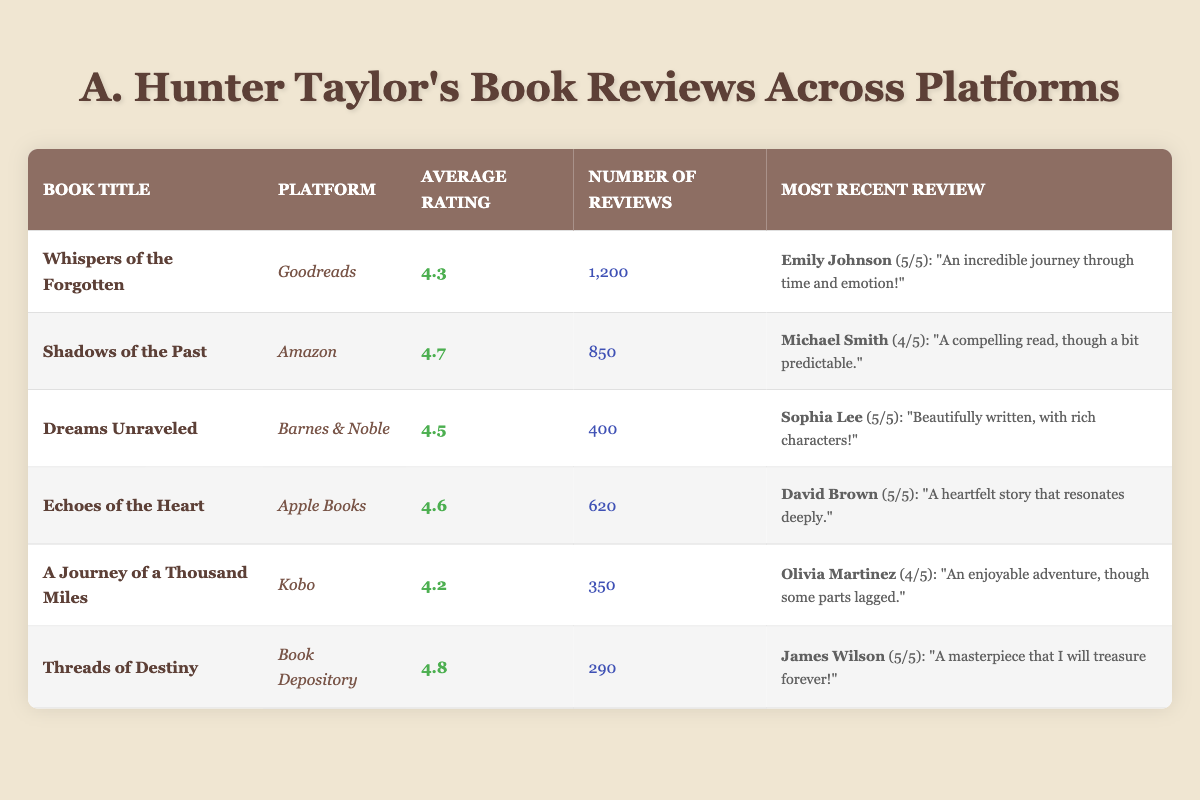What is the average rating of "Whispers of the Forgotten"? The table states that "Whispers of the Forgotten" has an average rating of 4.3 from Goodreads.
Answer: 4.3 Which book has the highest average rating? Upon reviewing the average ratings listed, "Threads of Destiny" has the highest rating of 4.8 among the books.
Answer: Threads of Destiny How many total reviews are there for all books combined? By adding the number of reviews for each book: 1200 + 850 + 400 + 620 + 350 + 290 = 3910 total reviews.
Answer: 3910 Did "Dreams Unraveled" receive more than 500 reviews? The number of reviews listed for "Dreams Unraveled" is 400, which is less than 500.
Answer: No What is the difference in average rating between the highest-rated and lowest-rated book? "Threads of Destiny" has the highest rating at 4.8, while "A Journey of a Thousand Miles" has the lowest rating at 4.2. The difference is 4.8 - 4.2 = 0.6.
Answer: 0.6 Who is the reviewer for the most recent review of "Echoes of the Heart"? The recent review for "Echoes of the Heart" is by David Brown, who rated it 5.
Answer: David Brown How many reviews did the book "Shadows of the Past" receive? The table shows that "Shadows of the Past" has received 850 reviews.
Answer: 850 Is the average rating of "A Journey of a Thousand Miles" below 4.5? The average rating for "A Journey of a Thousand Miles" is 4.2, which is indeed below 4.5.
Answer: Yes What is the average rating of books listed on Amazon? There is one book listed on Amazon, which is "Shadows of the Past" with an average rating of 4.7. Since there's only one book, the average is also 4.7.
Answer: 4.7 